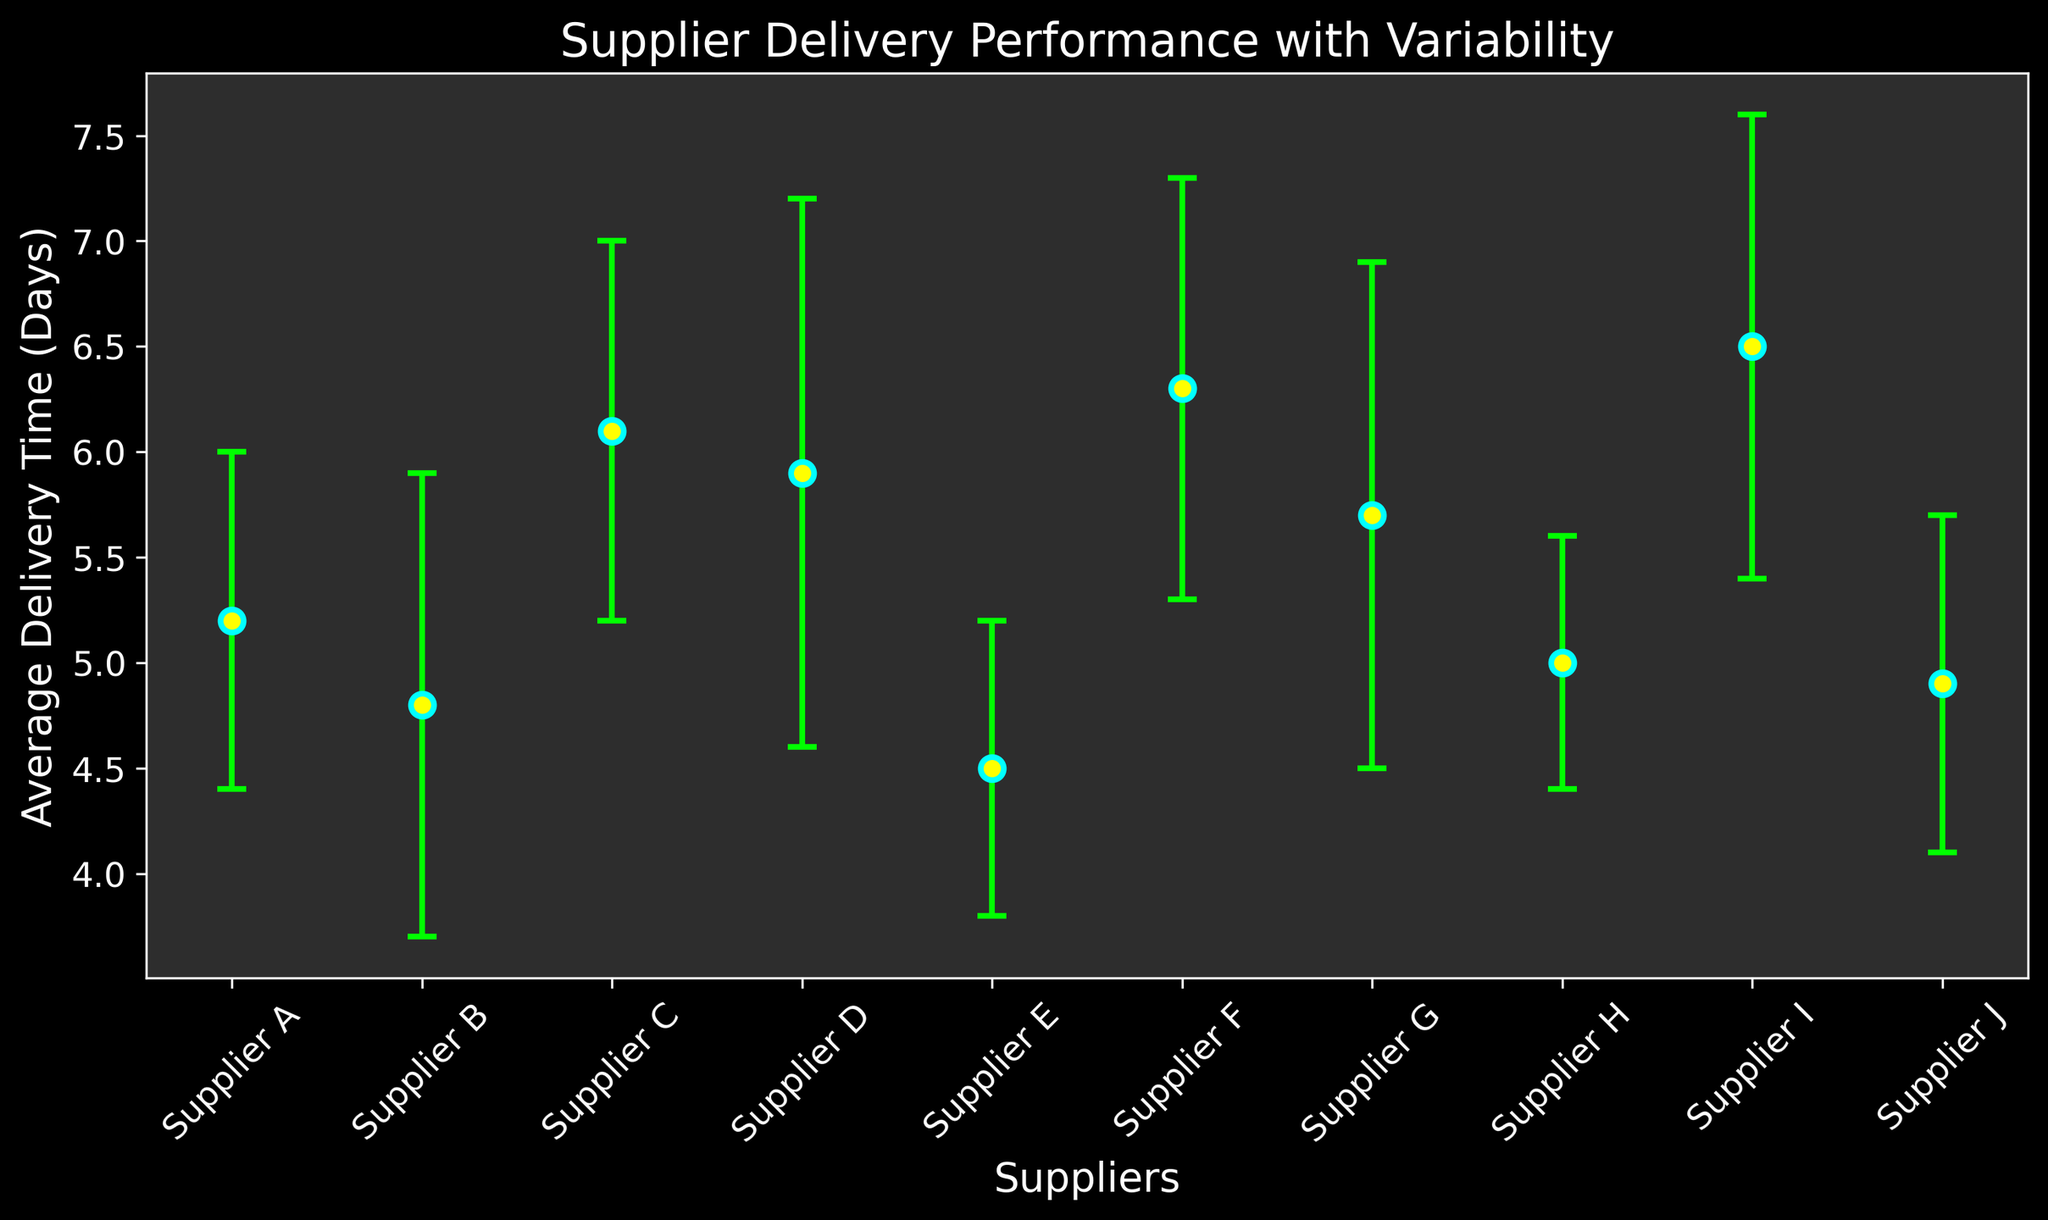Which supplier has the lowest average delivery time? By looking at the points on the chart, we can see that Supplier E has the lowest average delivery time as its point is the lowest along the y-axis.
Answer: Supplier E Which supplier has the highest average delivery time? According to the chart, Supplier I has the highest average delivery time as its point is the highest along the y-axis.
Answer: Supplier I What is the difference in average delivery time between Supplier I and Supplier E? Supplier I has an average delivery time of 6.5 days, and Supplier E has 4.5 days. The difference is calculated as 6.5 - 4.5.
Answer: 2 days Which supplier has the highest variability in delivery time? The error bar with the largest length corresponds to the highest standard deviation. Supplier D has the largest error bar, indicating the highest variability in delivery time.
Answer: Supplier D Comparing Supplier B and Supplier H, which one has a more consistent delivery time? Consistency in delivery time is indicated by a shorter error bar. Supplier H has a shorter error bar compared to Supplier B, indicating more consistency.
Answer: Supplier H Which suppliers have an average delivery time less than 5 days? By observing the points that fall below the 5 days mark on the y-axis: Supplier B, Supplier E, Supplier H, and Supplier J all meet this criterion.
Answer: Supplier B, Supplier E, Supplier H, Supplier J Which supplier has the closest average delivery time to 5 days with the least variability? Supplier H has an average delivery time of exactly 5 days with a standard deviation of 0.6, which is the least among the suppliers with average delivery times of around 5 days.
Answer: Supplier H What is the average delivery time difference between Supplier C and Supplier F? Supplier C has an average delivery time of 6.1 days, and Supplier F has 6.3 days. The difference is calculated as 6.3 - 6.1.
Answer: 0.2 days 